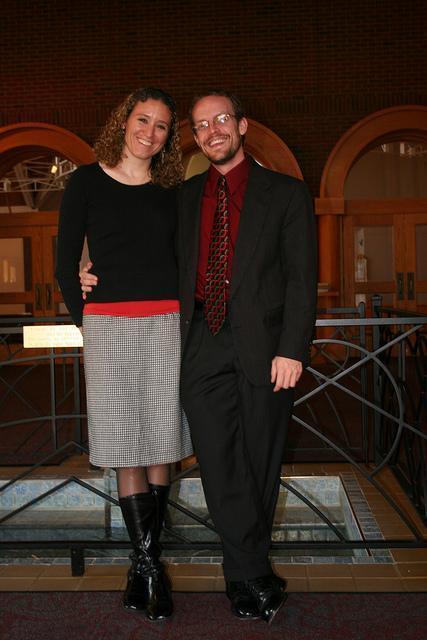How many women are here?
Give a very brief answer. 1. How many people are in the picture?
Give a very brief answer. 2. How many train cars are easily visible?
Give a very brief answer. 0. 